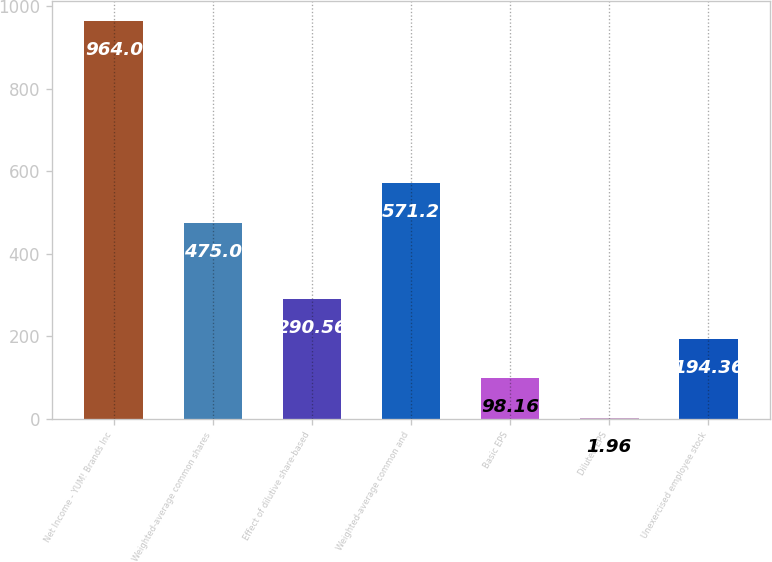<chart> <loc_0><loc_0><loc_500><loc_500><bar_chart><fcel>Net Income - YUM! Brands Inc<fcel>Weighted-average common shares<fcel>Effect of dilutive share-based<fcel>Weighted-average common and<fcel>Basic EPS<fcel>Diluted EPS<fcel>Unexercised employee stock<nl><fcel>964<fcel>475<fcel>290.56<fcel>571.2<fcel>98.16<fcel>1.96<fcel>194.36<nl></chart> 